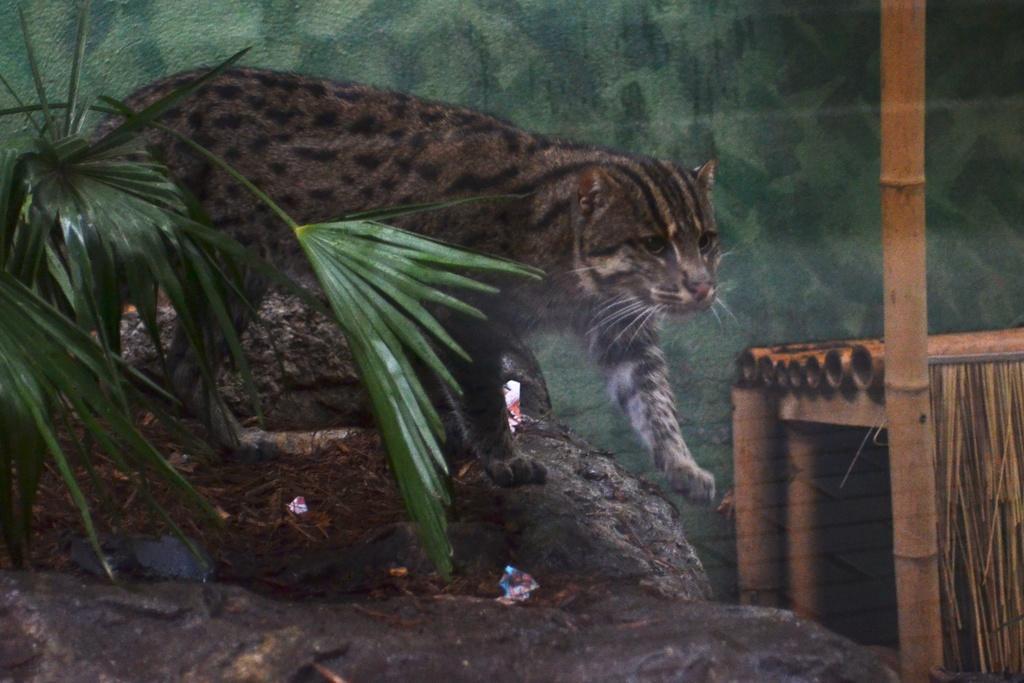Describe this image in one or two sentences. In this image there is a cat walking on the rocks, there is a plant towards the left of the image, there are wooden sticks towards the right of the image, at the background of the image there is a wall, the wall is green in color. 